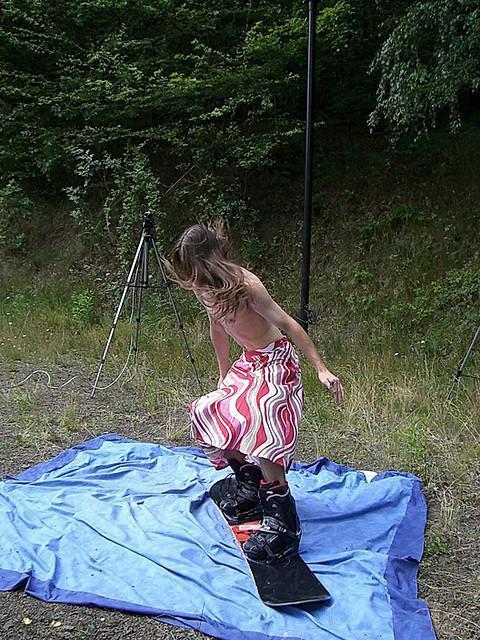How many keyboards are visible?
Give a very brief answer. 0. 